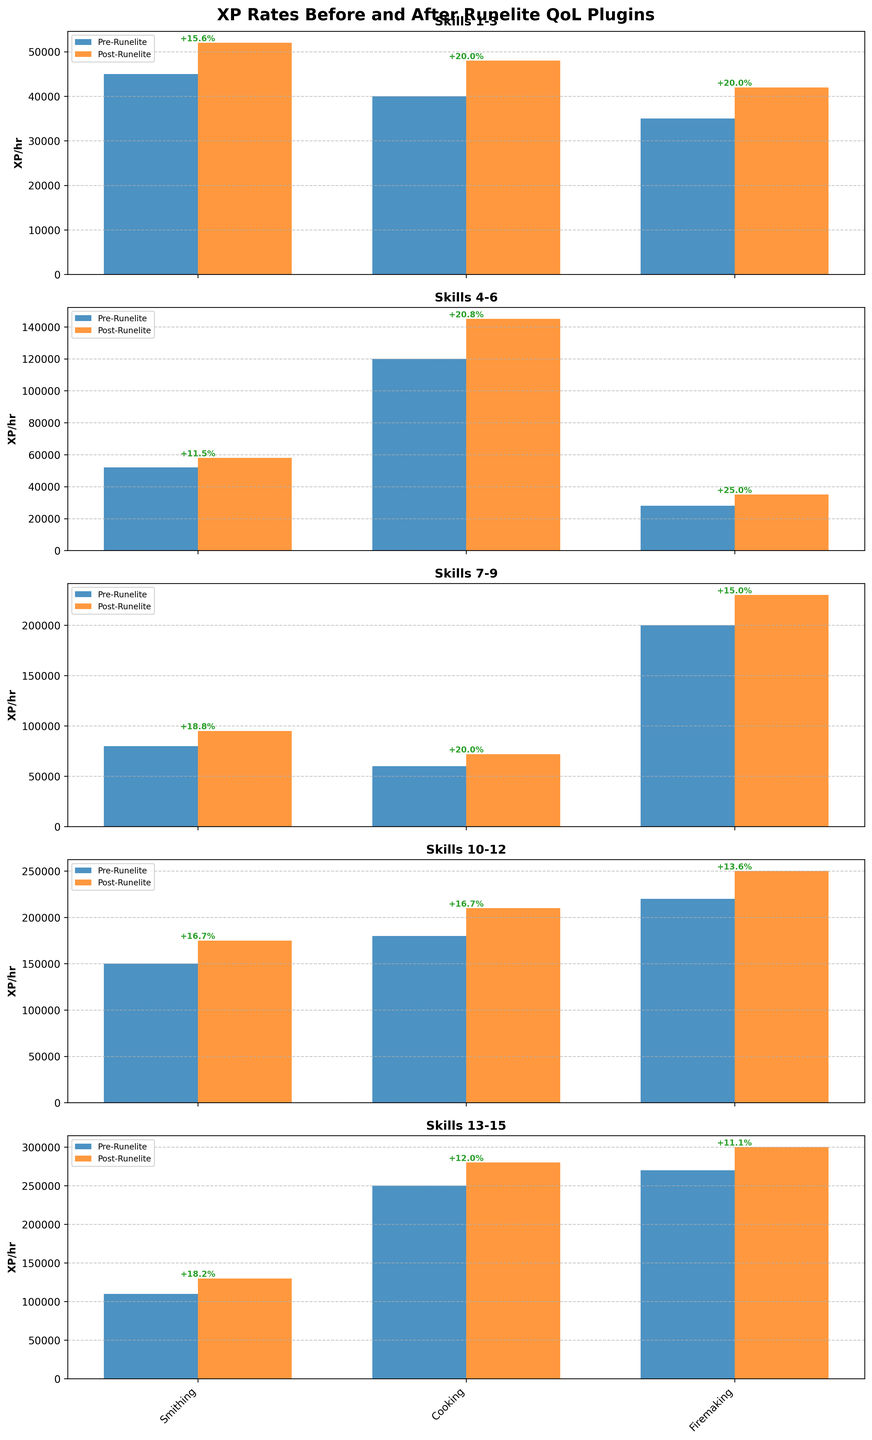Which skill shows the highest increase in XP rates after the Runelite QoL plugins were implemented? To determine this, look for the skill with the largest gap between the Post-Runelite bar (orange) and the Pre-Runelite bar (blue). The skill 'Thieving' has the largest increase from 120,000 XP/hr to 145,000 XP/hr.
Answer: Thieving Which skill has the smallest percentage increase in XP rates after Runelite QoL plugins were added? Calculate the percentage increase for each skill and find the smallest one. For 'Mining', the increase is from 45,000 XP/hr to 52,000 XP/hr which is approximately (52,000 - 45,000) / 45,000 * 100 = 15.6%.
Answer: Mining What is the total XP/hr gain for the skills displayed in the first subplot? Identify the skills in the first subplot (Mining, Woodcutting, Fishing), and sum up their XP/hr gains: (52000 - 45000) + (48000 - 40000) + (42000 - 35000) = 7000 + 8000 + 7000 = 22000 XP/hr.
Answer: 22000 Compare the average XP rates of skills in the fourth subplot before and after Runelite QoL plugins were added. The fourth subplot includes Farming, Construction, and Crafting. Calculate their averages: Pre-Runelite average = (60000 + 200000 + 150000) / 3 = 136,667 XP/hr; Post-Runelite average = (72000 + 230000 + 175000) / 3 = 159,000 XP/hr.
Answer: Pre-Runelite: 136667, Post-Runelite: 159000 How many skills have an XP rate increase larger than 25,000 XP/hr after implementing the Runelite QoL plugins? Check each skill's difference between Pre- and Post-Runelite XP/hr. Skills with increases larger than 25,000 XP/hr are 'Thieving', 'Hunter', 'Construction', 'Crafting', 'Fletching', 'Herblore', 'Cooking', and 'Firemaking' - a total of 8 skills.
Answer: 8 